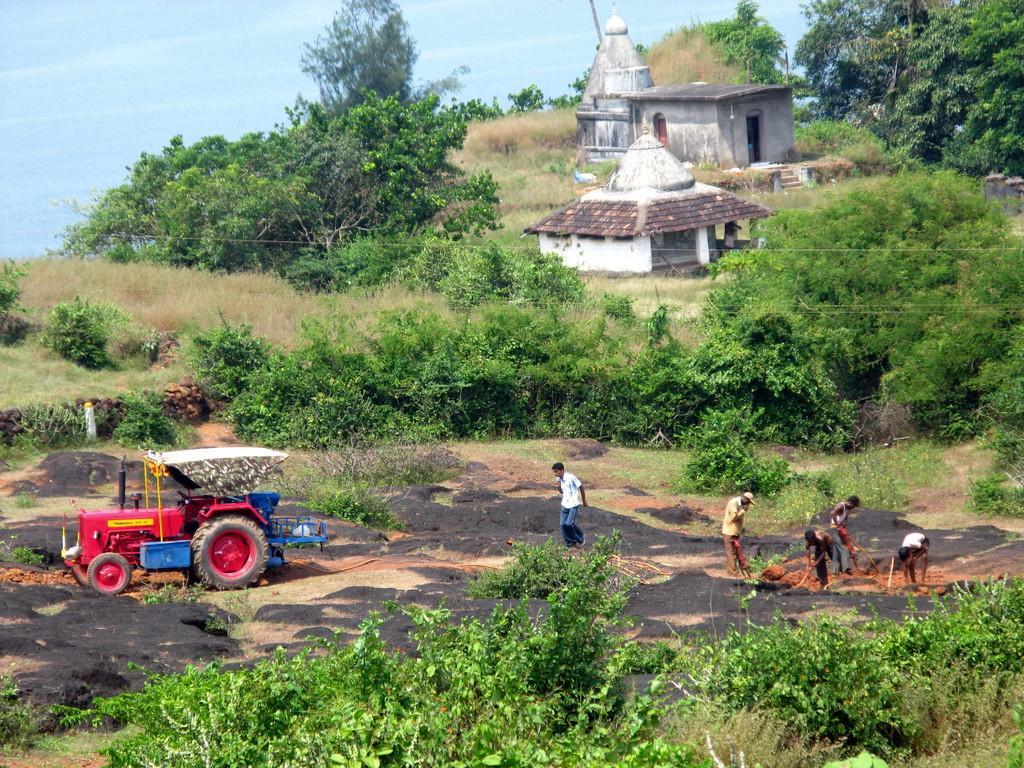In one or two sentences, can you explain what this image depicts? In this image I can see the grass. I can see some people. On the left side I can see a vehicle. In the background, I can see the trees and clouds in the sky. 